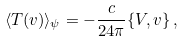Convert formula to latex. <formula><loc_0><loc_0><loc_500><loc_500>\langle T ( v ) \rangle _ { \psi } = - \frac { c } { 2 4 \pi } \{ V , v \} \, ,</formula> 